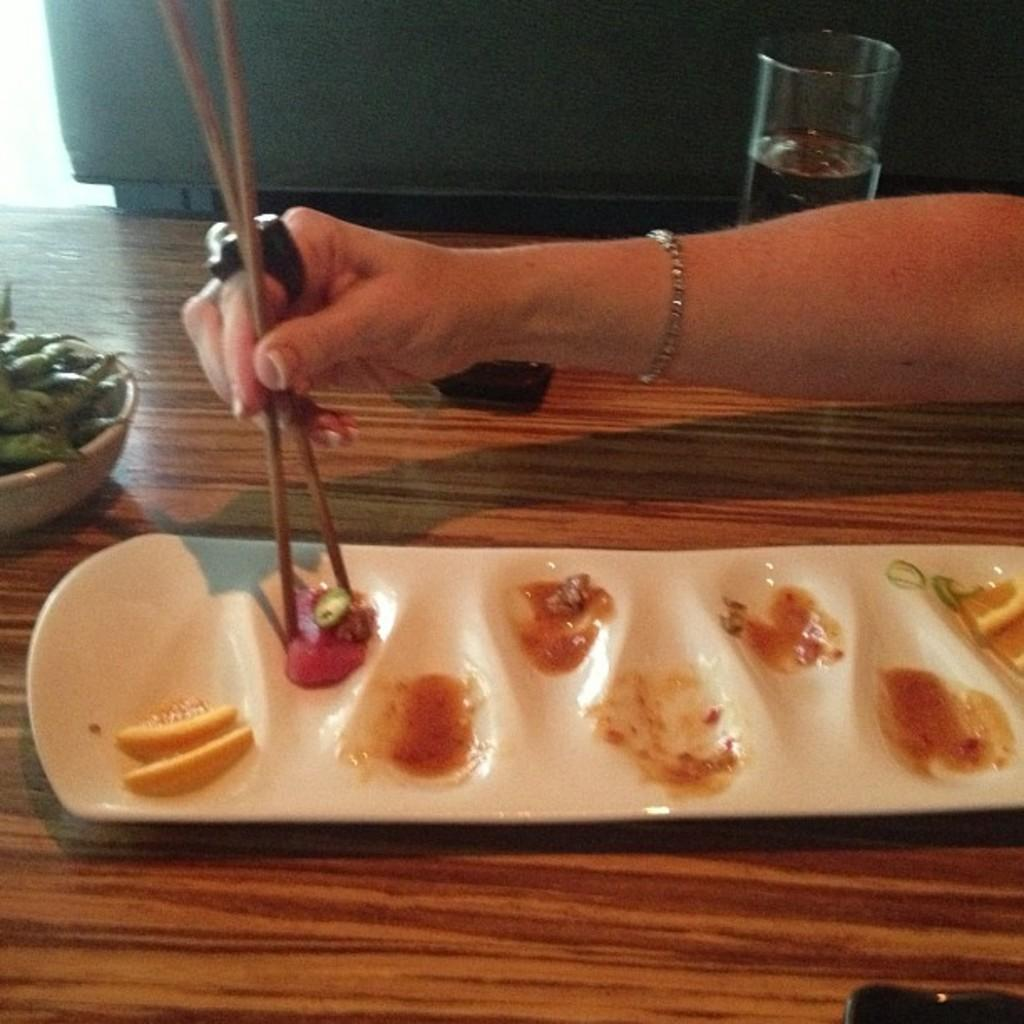What is on the plate that is visible in the image? There is a plate with food in the image. What utensil is being used in the image? A hand is holding chopsticks in the image. What other dish is present in the image? There is a bowl in the image. What beverage is visible in the image? There is a glass of water in the water in the image. What electronic device is on the table in the image? There is a mobile on the table in the image. What type of grain is being served at the party in the image? There is no party present in the image, and no grain is visible. What is the condition of the person's wrist in the image? There is no person's wrist visible in the image. 